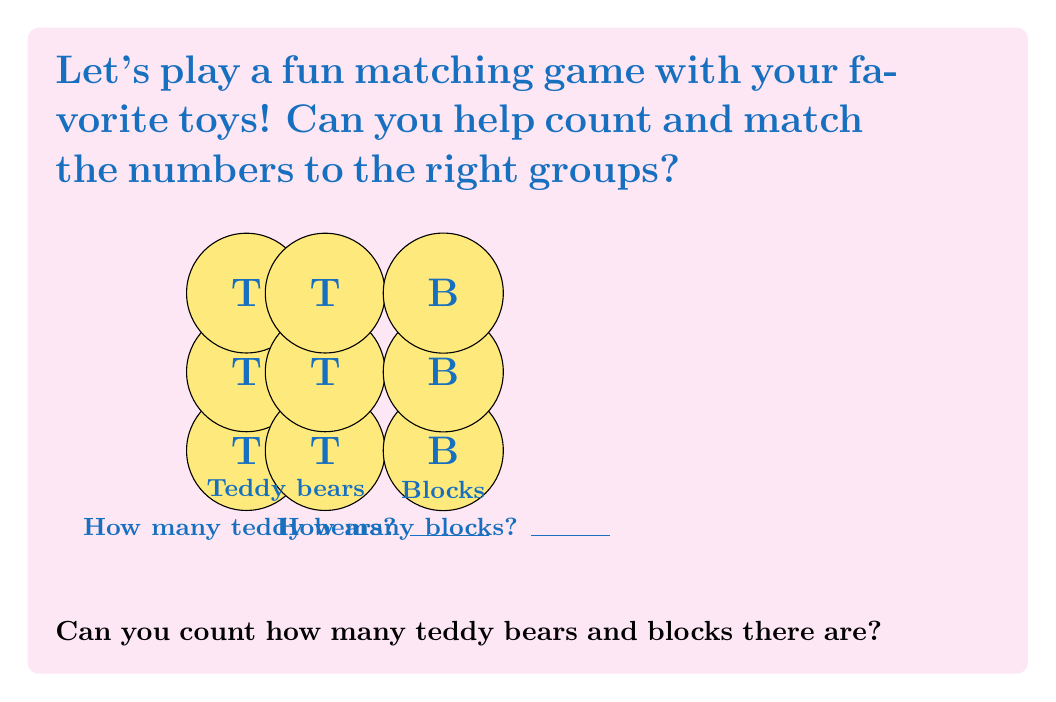Help me with this question. Let's count together, nice and slow:

1. Counting teddy bears:
   - We'll count each teddy bear one by one.
   - There are 2 rows of teddy bears.
   - In each row, we count: 1, 2, 3.
   - So, in total, we have: 3 + 3 = 6 teddy bears.

2. Counting blocks:
   - We'll count each block one by one.
   - There's only one column of blocks.
   - We count: 1, 2, 3.
   - So, there are 3 blocks in total.

Now we can match the numbers to our toy groups:
- Teddy bears: 6
- Blocks: 3

Remember, it's okay if counting takes a little time. You're doing great!
Answer: Teddy bears: 6, Blocks: 3 